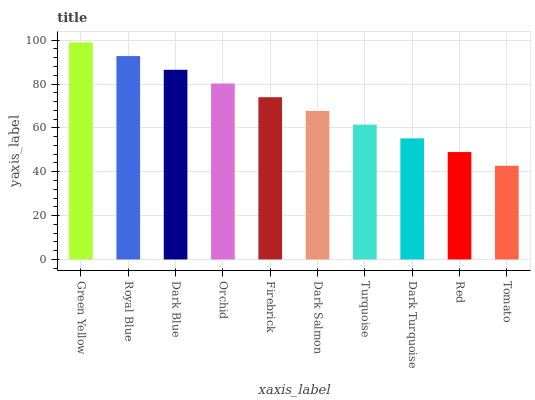Is Tomato the minimum?
Answer yes or no. Yes. Is Green Yellow the maximum?
Answer yes or no. Yes. Is Royal Blue the minimum?
Answer yes or no. No. Is Royal Blue the maximum?
Answer yes or no. No. Is Green Yellow greater than Royal Blue?
Answer yes or no. Yes. Is Royal Blue less than Green Yellow?
Answer yes or no. Yes. Is Royal Blue greater than Green Yellow?
Answer yes or no. No. Is Green Yellow less than Royal Blue?
Answer yes or no. No. Is Firebrick the high median?
Answer yes or no. Yes. Is Dark Salmon the low median?
Answer yes or no. Yes. Is Dark Salmon the high median?
Answer yes or no. No. Is Tomato the low median?
Answer yes or no. No. 